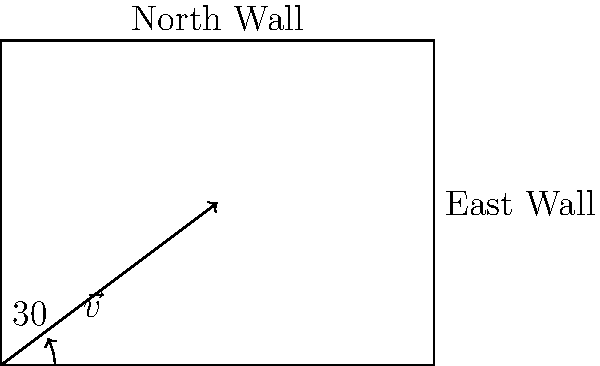A thermal insulation vector $\vec{v}$ with a magnitude of 10 W/m²·K is oriented at a 30° angle from the horizontal, as shown in the diagram. Calculate the component of this vector that is perpendicular to the north wall, representing the effective thermal insulation for that wall orientation. To solve this problem, we need to follow these steps:

1. Identify the vector components:
   The vector $\vec{v}$ can be decomposed into horizontal (x) and vertical (y) components.

2. Calculate the vertical component:
   The vertical component represents the effective insulation for the north wall.
   Using trigonometry, we can find this component:
   
   $v_y = |\vec{v}| \cdot \sin(30°)$

3. Calculate the numerical value:
   $v_y = 10 \cdot \sin(30°)$
   $v_y = 10 \cdot 0.5 = 5$ W/m²·K

The component of the thermal insulation vector perpendicular to the north wall is 5 W/m²·K. This value represents the effective thermal insulation for the north wall orientation.
Answer: 5 W/m²·K 